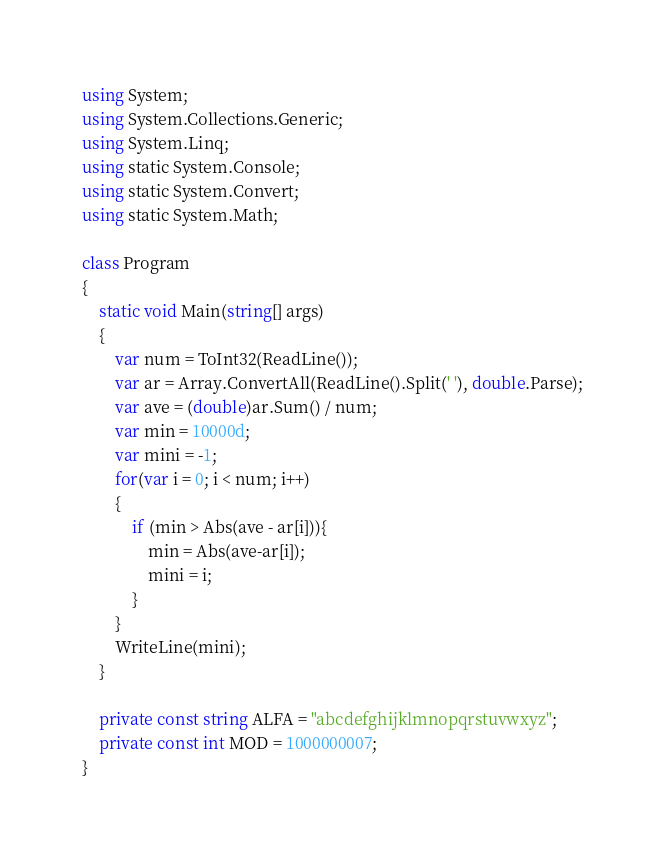Convert code to text. <code><loc_0><loc_0><loc_500><loc_500><_C#_>using System;
using System.Collections.Generic;
using System.Linq;
using static System.Console;
using static System.Convert;
using static System.Math;

class Program
{
    static void Main(string[] args)
    {
        var num = ToInt32(ReadLine());
        var ar = Array.ConvertAll(ReadLine().Split(' '), double.Parse);
        var ave = (double)ar.Sum() / num;
        var min = 10000d;
        var mini = -1;
        for(var i = 0; i < num; i++)
        {
            if (min > Abs(ave - ar[i])){
                min = Abs(ave-ar[i]);
                mini = i;
            }
        }
        WriteLine(mini);
    }

    private const string ALFA = "abcdefghijklmnopqrstuvwxyz";
    private const int MOD = 1000000007;
}
</code> 